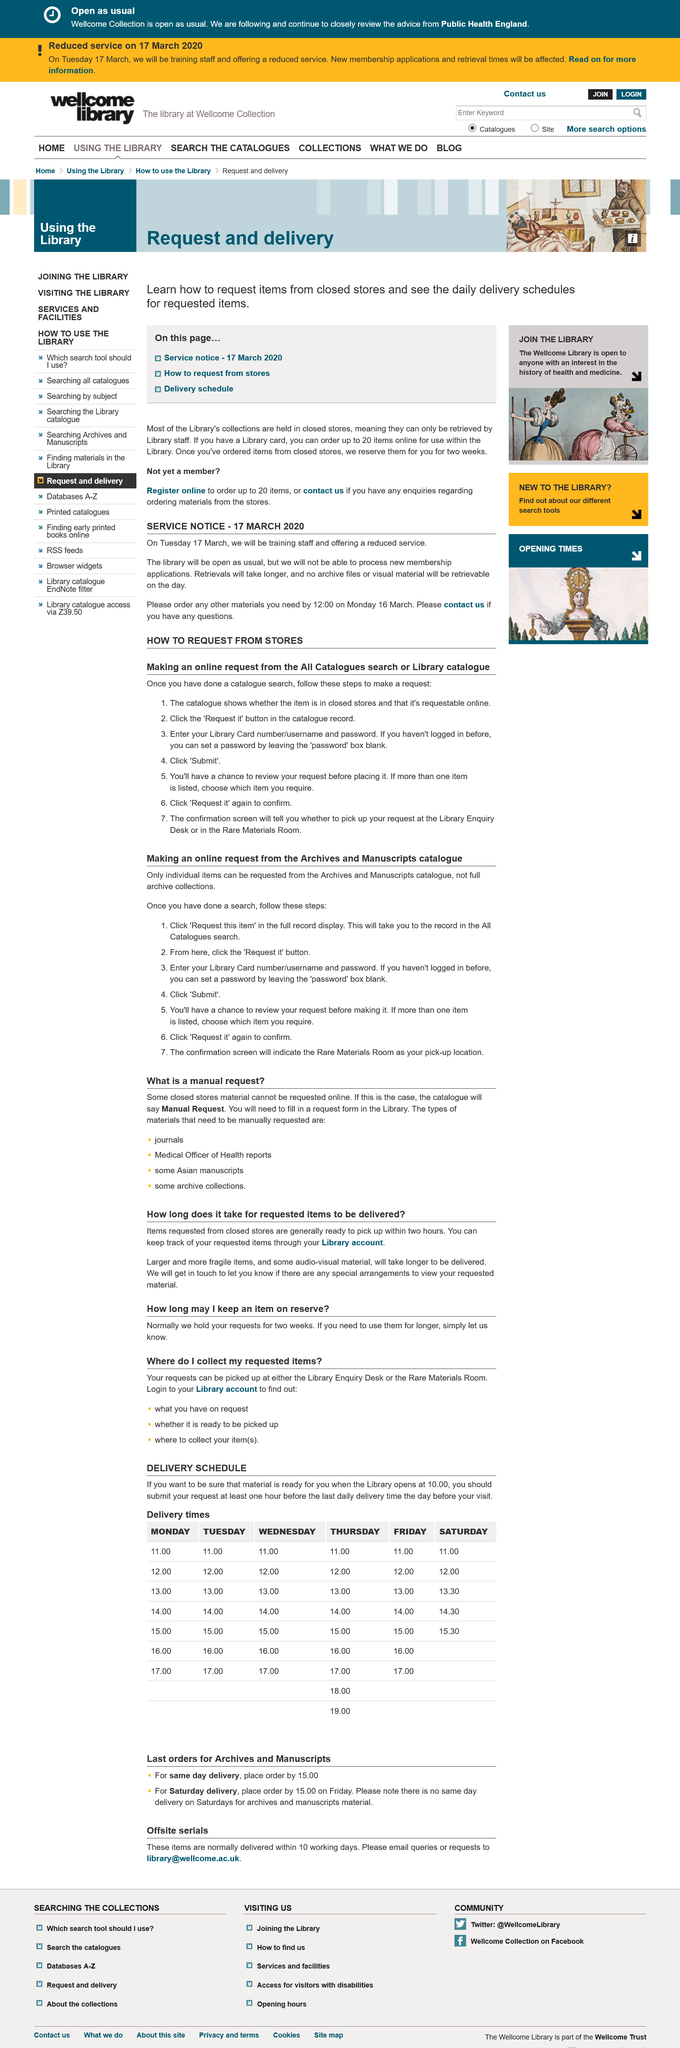Point out several critical features in this image. In general, requested items are ready within 2 hours. You can keep track of your requested items through your Library account. It is necessary for any other materials to be ordered by 12:00 on Monday, March 16th. A reduced service will be offered beginning on Tuesday, March 17th, 2020. It is expected that larger, more fragile, and audio-visual items will take longer to be delivered. 